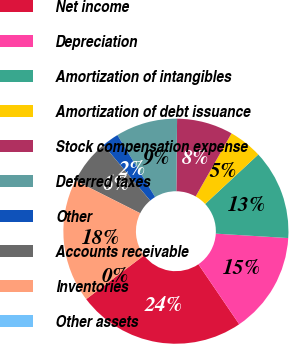<chart> <loc_0><loc_0><loc_500><loc_500><pie_chart><fcel>Net income<fcel>Depreciation<fcel>Amortization of intangibles<fcel>Amortization of debt issuance<fcel>Stock compensation expense<fcel>Deferred taxes<fcel>Other<fcel>Accounts receivable<fcel>Inventories<fcel>Other assets<nl><fcel>24.19%<fcel>14.52%<fcel>12.9%<fcel>4.84%<fcel>8.06%<fcel>8.87%<fcel>2.42%<fcel>6.45%<fcel>17.74%<fcel>0.0%<nl></chart> 